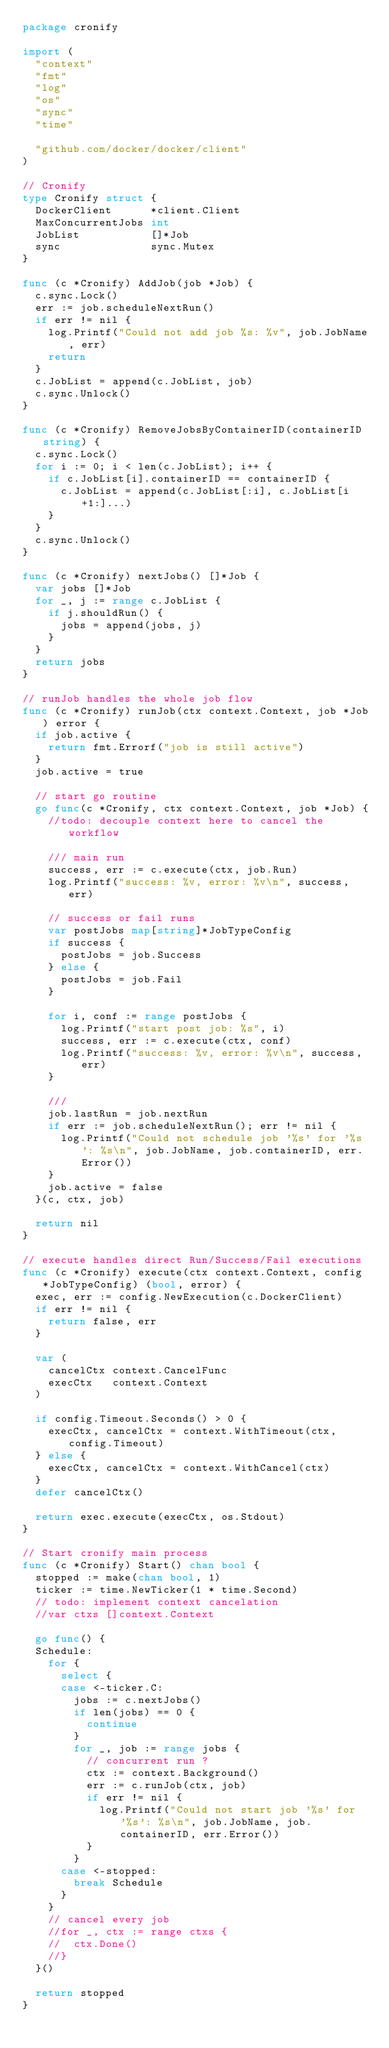Convert code to text. <code><loc_0><loc_0><loc_500><loc_500><_Go_>package cronify

import (
	"context"
	"fmt"
	"log"
	"os"
	"sync"
	"time"

	"github.com/docker/docker/client"
)

// Cronify
type Cronify struct {
	DockerClient      *client.Client
	MaxConcurrentJobs int
	JobList           []*Job
	sync              sync.Mutex
}

func (c *Cronify) AddJob(job *Job) {
	c.sync.Lock()
	err := job.scheduleNextRun()
	if err != nil {
		log.Printf("Could not add job %s: %v", job.JobName, err)
		return
	}
	c.JobList = append(c.JobList, job)
	c.sync.Unlock()
}

func (c *Cronify) RemoveJobsByContainerID(containerID string) {
	c.sync.Lock()
	for i := 0; i < len(c.JobList); i++ {
		if c.JobList[i].containerID == containerID {
			c.JobList = append(c.JobList[:i], c.JobList[i+1:]...)
		}
	}
	c.sync.Unlock()
}

func (c *Cronify) nextJobs() []*Job {
	var jobs []*Job
	for _, j := range c.JobList {
		if j.shouldRun() {
			jobs = append(jobs, j)
		}
	}
	return jobs
}

// runJob handles the whole job flow
func (c *Cronify) runJob(ctx context.Context, job *Job) error {
	if job.active {
		return fmt.Errorf("job is still active")
	}
	job.active = true

	// start go routine
	go func(c *Cronify, ctx context.Context, job *Job) {
		//todo: decouple context here to cancel the workflow

		/// main run
		success, err := c.execute(ctx, job.Run)
		log.Printf("success: %v, error: %v\n", success, err)

		// success or fail runs
		var postJobs map[string]*JobTypeConfig
		if success {
			postJobs = job.Success
		} else {
			postJobs = job.Fail
		}

		for i, conf := range postJobs {
			log.Printf("start post job: %s", i)
			success, err := c.execute(ctx, conf)
			log.Printf("success: %v, error: %v\n", success, err)
		}

		///
		job.lastRun = job.nextRun
		if err := job.scheduleNextRun(); err != nil {
			log.Printf("Could not schedule job '%s' for '%s': %s\n", job.JobName, job.containerID, err.Error())
		}
		job.active = false
	}(c, ctx, job)

	return nil
}

// execute handles direct Run/Success/Fail executions
func (c *Cronify) execute(ctx context.Context, config *JobTypeConfig) (bool, error) {
	exec, err := config.NewExecution(c.DockerClient)
	if err != nil {
		return false, err
	}

	var (
		cancelCtx context.CancelFunc
		execCtx   context.Context
	)

	if config.Timeout.Seconds() > 0 {
		execCtx, cancelCtx = context.WithTimeout(ctx, config.Timeout)
	} else {
		execCtx, cancelCtx = context.WithCancel(ctx)
	}
	defer cancelCtx()

	return exec.execute(execCtx, os.Stdout)
}

// Start cronify main process
func (c *Cronify) Start() chan bool {
	stopped := make(chan bool, 1)
	ticker := time.NewTicker(1 * time.Second)
	// todo: implement context cancelation
	//var ctxs []context.Context

	go func() {
	Schedule:
		for {
			select {
			case <-ticker.C:
				jobs := c.nextJobs()
				if len(jobs) == 0 {
					continue
				}
				for _, job := range jobs {
					// concurrent run ?
					ctx := context.Background()
					err := c.runJob(ctx, job)
					if err != nil {
						log.Printf("Could not start job '%s' for '%s': %s\n", job.JobName, job.containerID, err.Error())
					}
				}
			case <-stopped:
				break Schedule
			}
		}
		// cancel every job
		//for _, ctx := range ctxs {
		//	ctx.Done()
		//}
	}()

	return stopped
}
</code> 